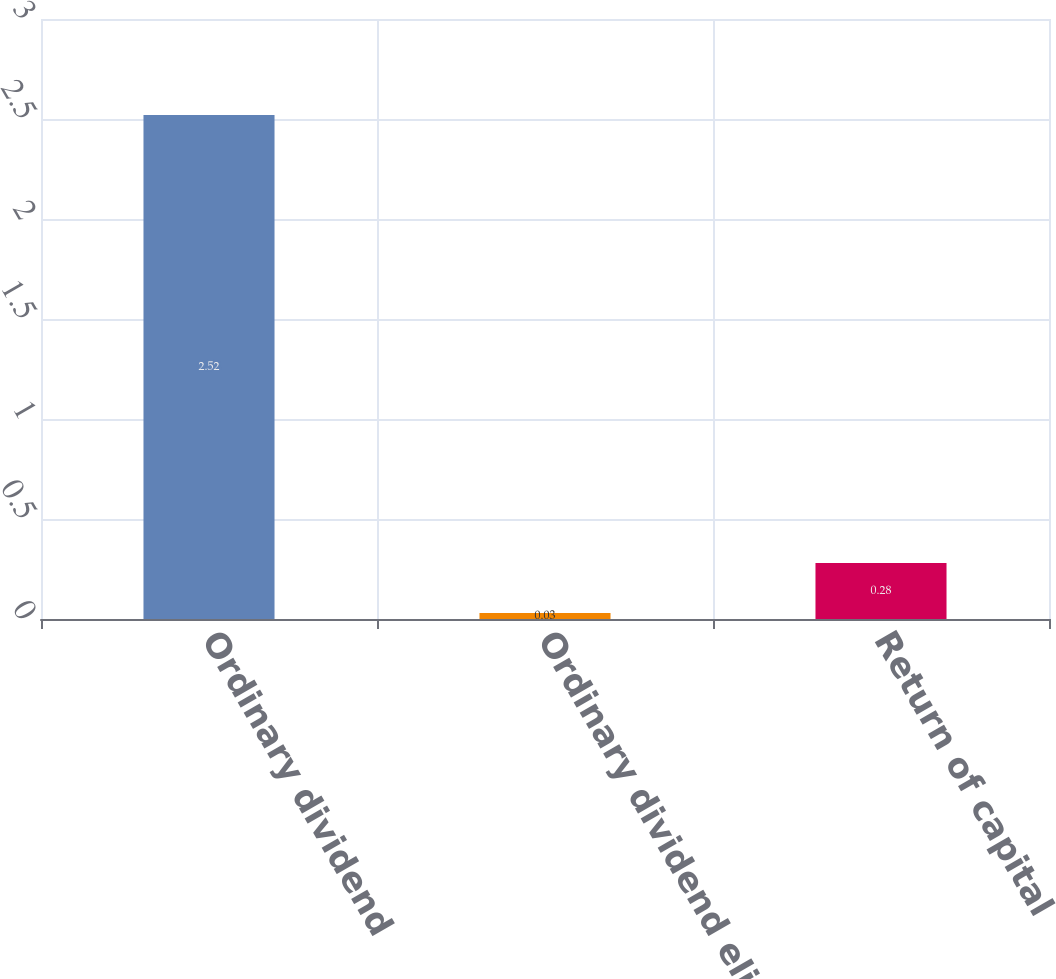Convert chart. <chart><loc_0><loc_0><loc_500><loc_500><bar_chart><fcel>Ordinary dividend<fcel>Ordinary dividend eligible for<fcel>Return of capital<nl><fcel>2.52<fcel>0.03<fcel>0.28<nl></chart> 